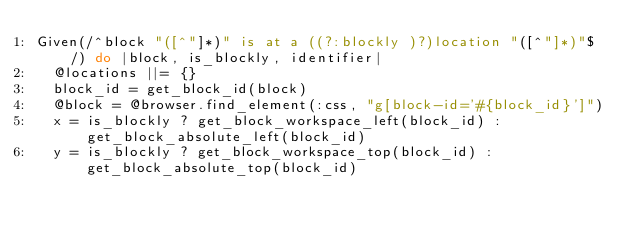Convert code to text. <code><loc_0><loc_0><loc_500><loc_500><_Ruby_>Given(/^block "([^"]*)" is at a ((?:blockly )?)location "([^"]*)"$/) do |block, is_blockly, identifier|
  @locations ||= {}
  block_id = get_block_id(block)
  @block = @browser.find_element(:css, "g[block-id='#{block_id}']")
  x = is_blockly ? get_block_workspace_left(block_id) : get_block_absolute_left(block_id)
  y = is_blockly ? get_block_workspace_top(block_id) : get_block_absolute_top(block_id)</code> 